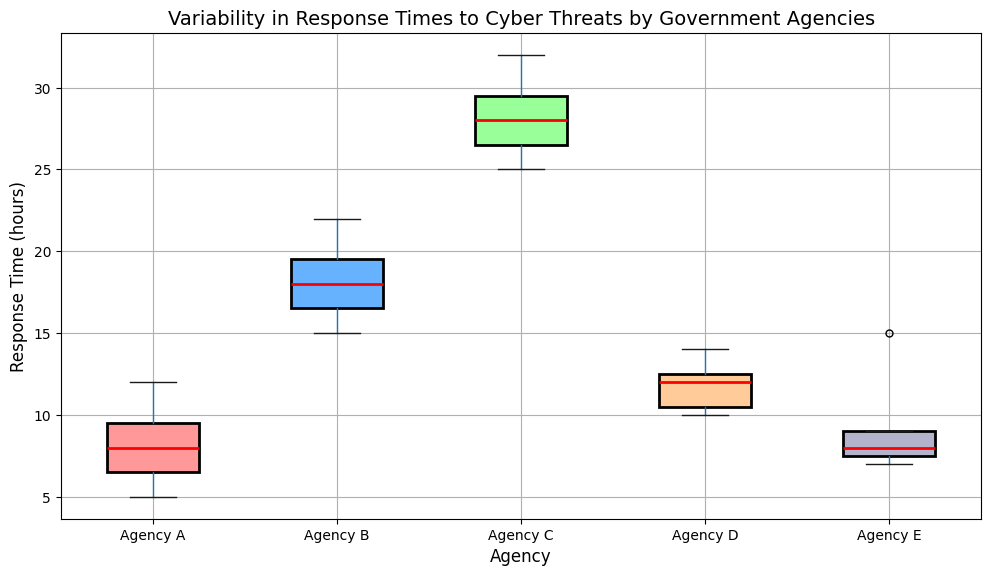What is the median response time for Agency A? To find the median response time for Agency A, locate the middle value in the sorted list of response times for Agency A. The sorted times are [5, 6, 7, 8, 9, 10, 12]. The middle value is 8.
Answer: 8 Which agency has the highest median response time? Observe the red lines that represent the medians in the boxplot and identify the agency with the highest median. Agency C has the highest median response time.
Answer: Agency C How does the variability of response times for Agency B compare to that of Agency D? Compare the lengths of the boxes and the whiskers for Agency B and Agency D. Agency B has a wider box and longer whiskers, indicating greater variability compared to Agency D.
Answer: Agency B shows more variability What is the range of response times for Agency E? The range is the difference between the maximum and minimum values. For Agency E, the minimum value is 7 and the maximum value is 15, so the range is 15 - 7 = 8.
Answer: 8 Which agency has the smallest interquartile range (IQR) and what does it indicate? The IQR is the distance between the first quartile (Q1) and the third quartile (Q3). The smallest IQR can be found by comparing the heights of the boxes. Agency E has the smallest IQR, indicating less variability in its middle 50% of response times.
Answer: Agency E Are there any outliers visible in the data, and if so, for which agencies? Outliers in a boxplot are typically represented by individual points outside the whiskers. Check each agency for such points. There are no visible outliers in the plot for any of the agencies.
Answer: No outliers Which agency has the closest 25th percentile to its median response time? The 25th percentile (Q1) is the bottom edge of the box, and the median is the red line in the box. Check the height difference between these two for each agency. Agency D has the closest 25th percentile to its median.
Answer: Agency D What is the maximum response time for Agency C? Look at the top whisker or the highest point for Agency C. The maximum response time is 32 hours.
Answer: 32 Which agency has the most consistent response times, and how can you tell? Consistent response times are indicated by a smaller IQR and shorter whiskers. Agency E has the most consistent response times, as shown by its small IQR and short whiskers.
Answer: Agency E What is the interquartile range (IQR) for Agency B? The IQR is the difference between the third quartile (Q3) and the first quartile (Q1). For Agency B, Q3 is approximately 21 and Q1 is approximately 16, so IQR = 21 - 16 = 5.
Answer: 5 